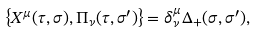Convert formula to latex. <formula><loc_0><loc_0><loc_500><loc_500>\left \{ X ^ { \mu } ( \tau , \sigma ) , \Pi _ { \nu } ( \tau , \sigma ^ { \prime } ) \right \} = \delta ^ { \mu } _ { \nu } \Delta _ { + } ( \sigma , \sigma ^ { \prime } ) ,</formula> 